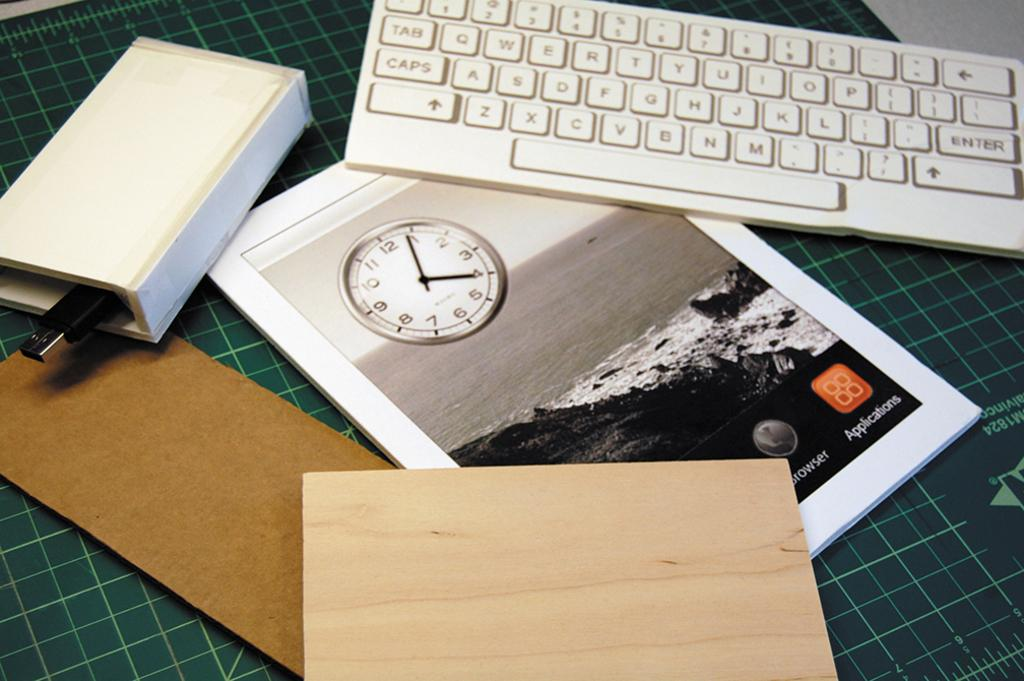<image>
Create a compact narrative representing the image presented. Magazine that shows a clock and the word "Applications" on the bottom. 